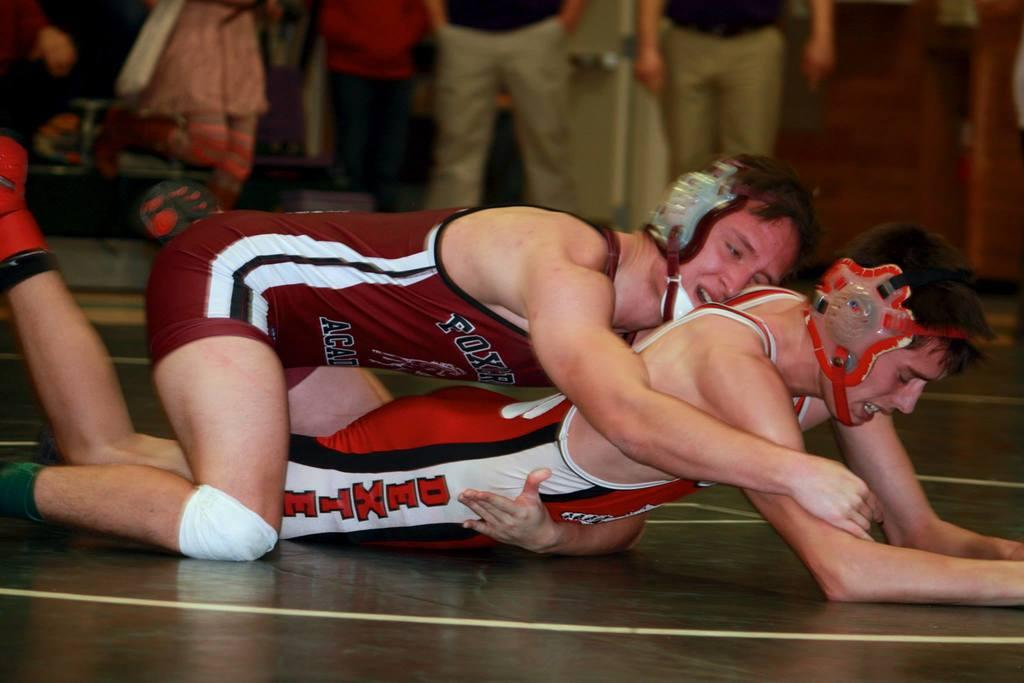How many people are in the image? There are two men in the image. What are the two men doing in the image? The two men are fighting. What is the surface on which the men are fighting? There is a floor in the image. Can you describe the background of the image? There are people standing in the background of the image. What is the profit made by the water in the image? There is no water present in the image, so there is no profit to be made. 